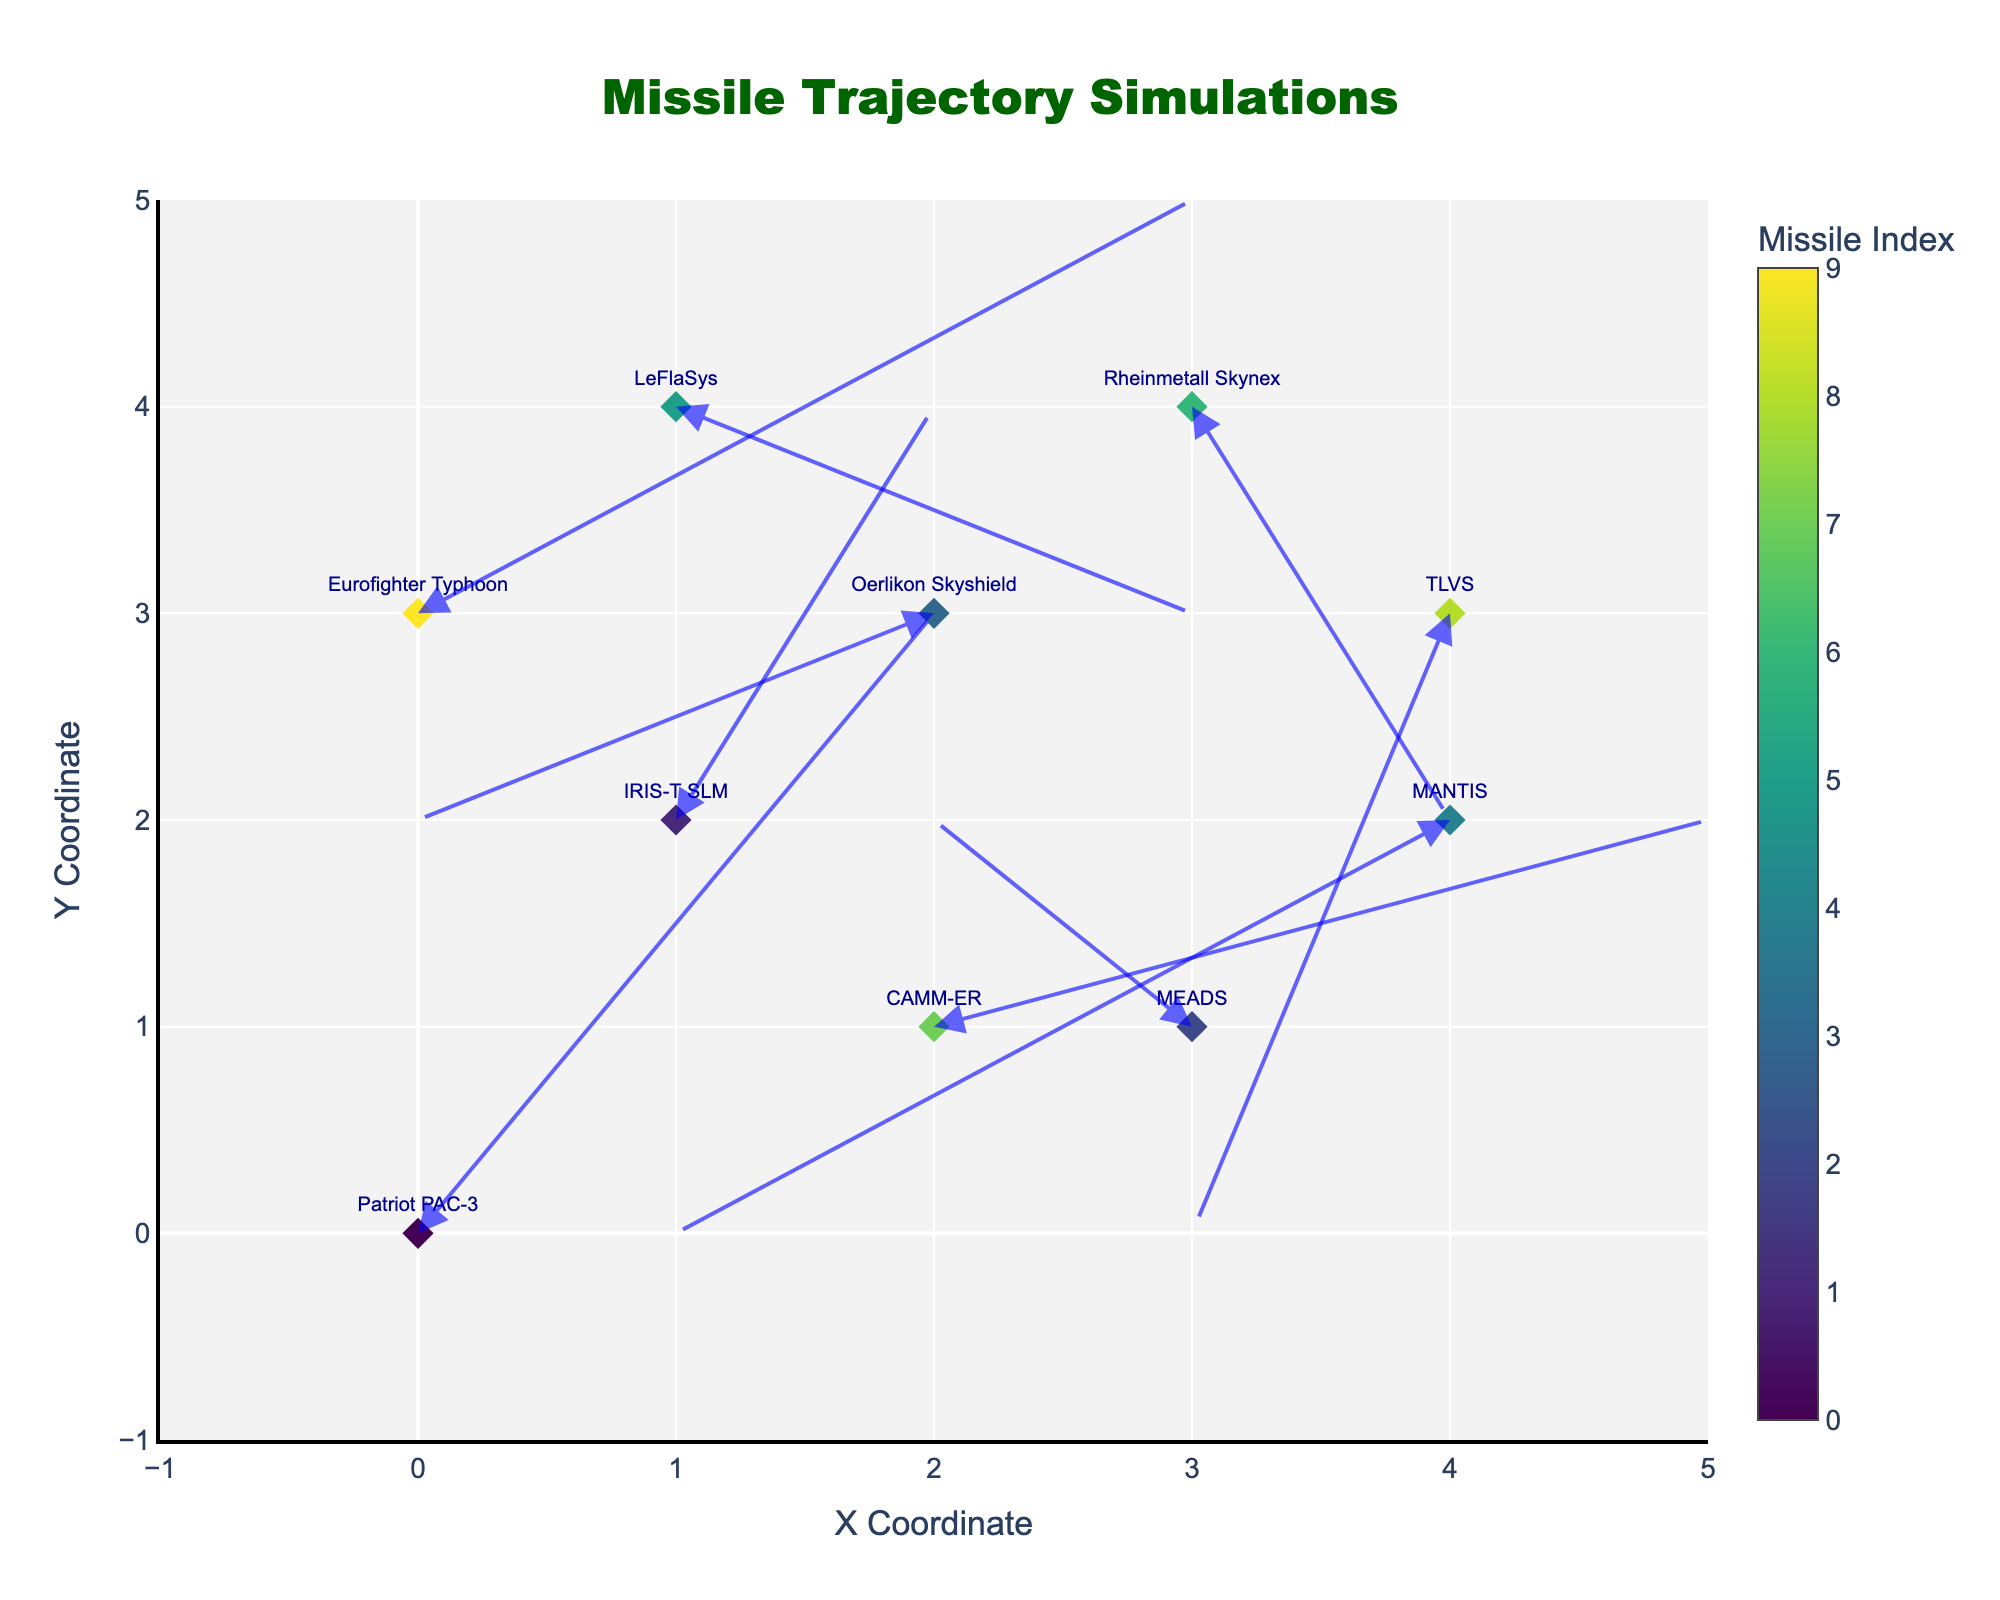How many missile trajectories are shown in the quiver plot? There are diamonds representing each missile's starting position in the plot. Counting these diamonds gives the number of trajectories.
Answer: 10 What is the title of the quiver plot? The title is positioned at the top of the plot and describes the content of the figure.
Answer: "Missile Trajectory Simulations" Which missile type originates at the position (1,2)? The position (1,2) can be located on the plot. The text near that position will state the missile type.
Answer: IRIS-T SLM What are the x and y ranges of the plot? The x and y axes ranges are labeled at the ends of the axes. They define the minimum and maximum values shown.
Answer: -1 to 5 Which missile has the longest trajectory, and what is its length? The length of the trajectory can be determined by the magnitude of the arrow. Measure the longest arrow from its base to its tip.
Answer: Eurofighter Typhoon What are the coordinates and displacement vector (u, v) for the Patriot PAC-3 missile? Find the initial coordinates (x, y) of the missile and the arrow representing its displacement (u, v).
Answer: (0,0), (2,3) Which missile trajectory indicates movement towards the origin (0,0)? Check each arrow to see if it points towards (0,0).
Answer: Oerlikon Skyshield Which trajectory has the smallest positive x-displacement (u)? Among the positive x-displacement values (u), the smallest one is identified.
Answer: IRIS-T SLM Which two missiles start their trajectories at the same y-coordinate and what is that y-coordinate? Identify missiles sharing the same starting y-coordinate by looking at the left-side labels.
Answer: LeFlaSys and Rheinmetall Skynex, y=4 What is the total vertical displacement (sum of v) of all missile trajectories? Sum the vertical components (v) of each missile's trajectory. Calculation: 3 + 2 + 1 -1 -2 -1 -2 + 1 -3 + 2 = 0
Answer: 0 